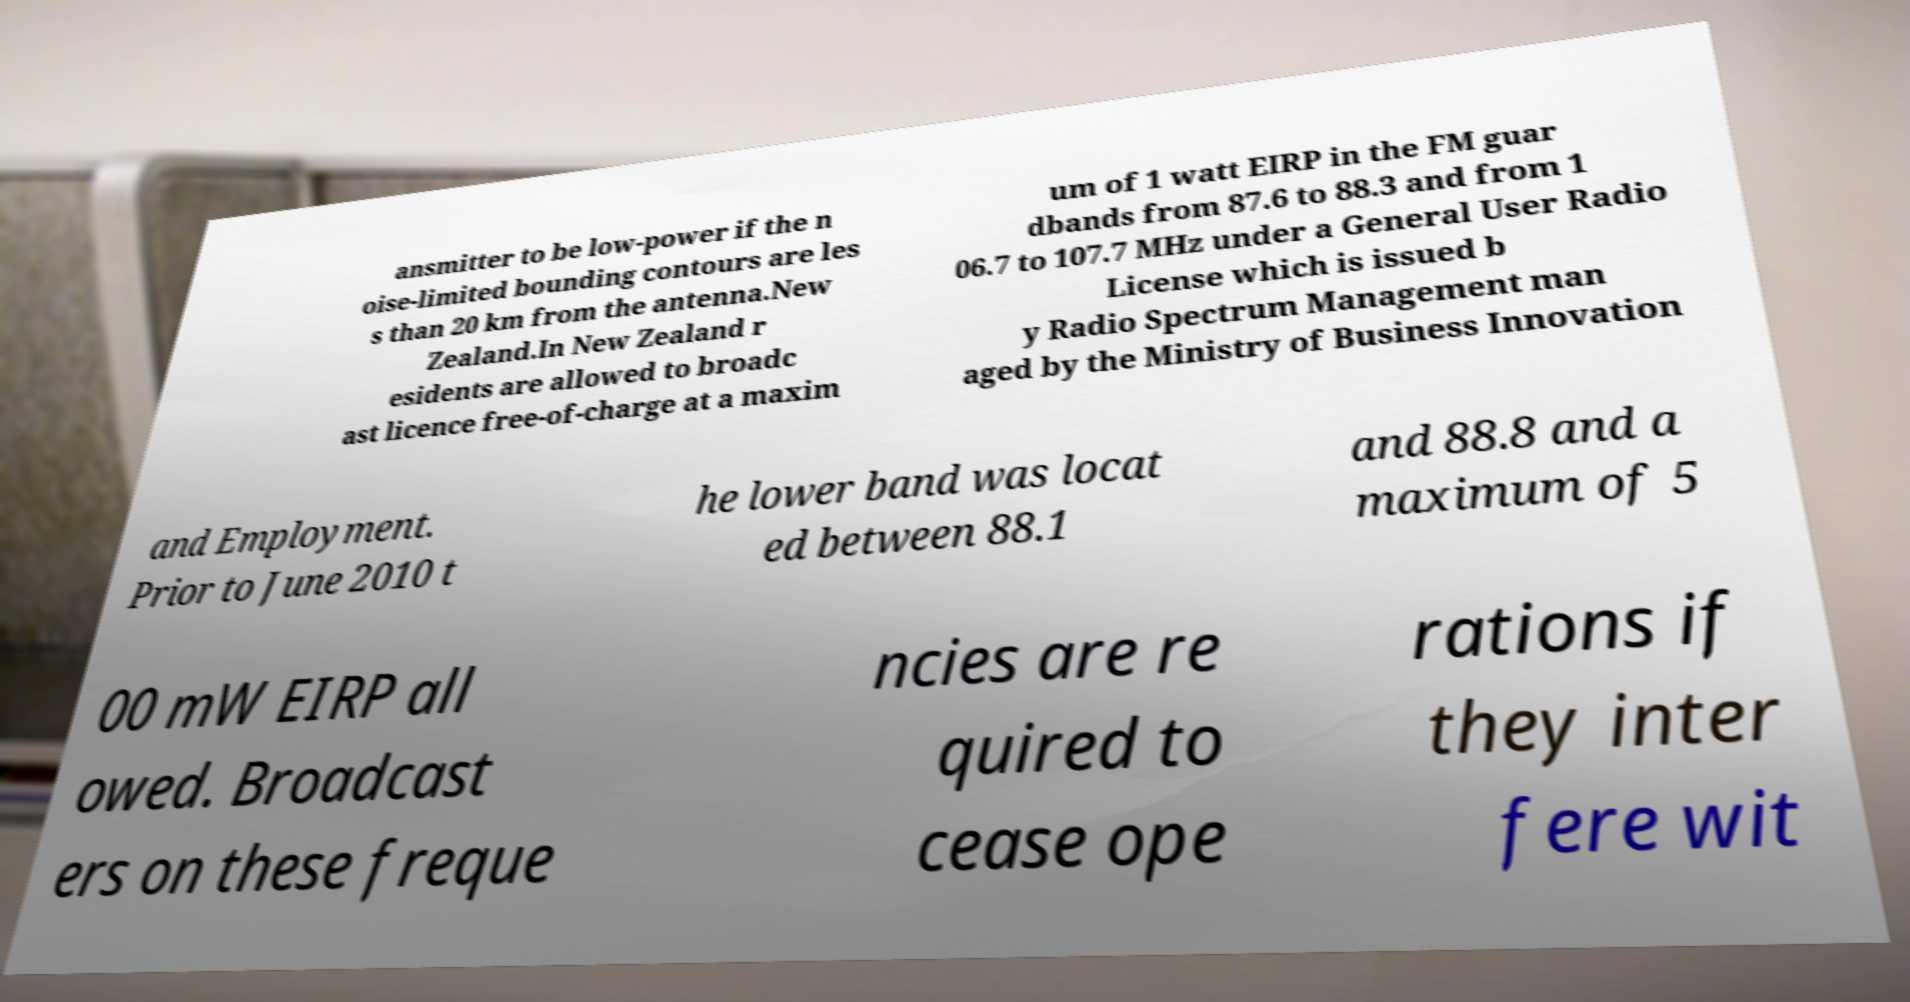Can you accurately transcribe the text from the provided image for me? ansmitter to be low-power if the n oise-limited bounding contours are les s than 20 km from the antenna.New Zealand.In New Zealand r esidents are allowed to broadc ast licence free-of-charge at a maxim um of 1 watt EIRP in the FM guar dbands from 87.6 to 88.3 and from 1 06.7 to 107.7 MHz under a General User Radio License which is issued b y Radio Spectrum Management man aged by the Ministry of Business Innovation and Employment. Prior to June 2010 t he lower band was locat ed between 88.1 and 88.8 and a maximum of 5 00 mW EIRP all owed. Broadcast ers on these freque ncies are re quired to cease ope rations if they inter fere wit 